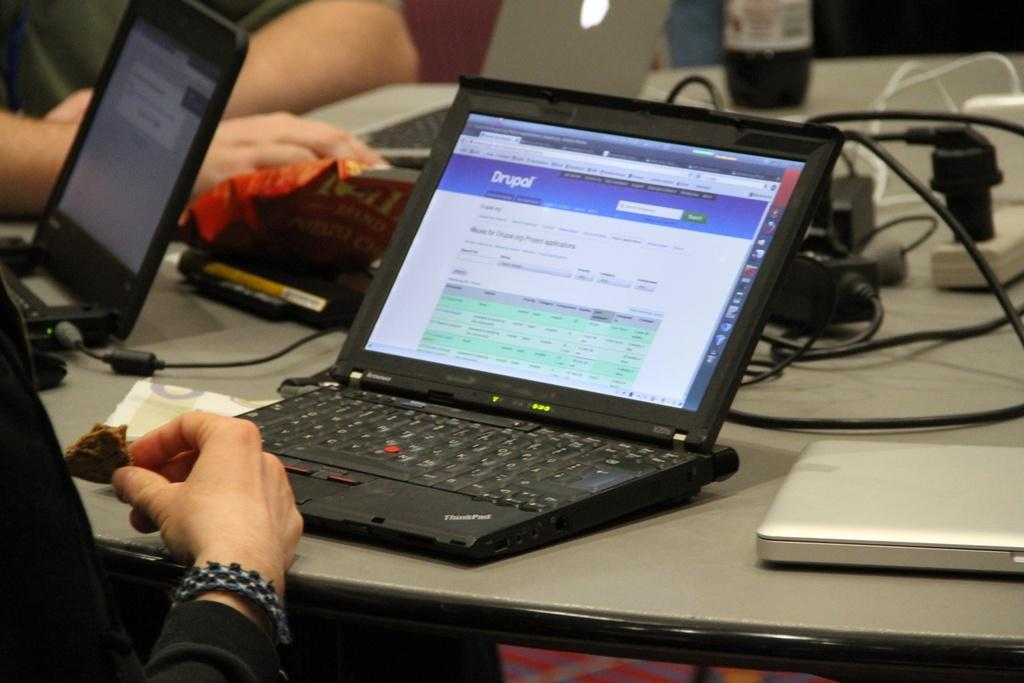<image>
Share a concise interpretation of the image provided. a black lap top computer open to a website named DRUPAL 